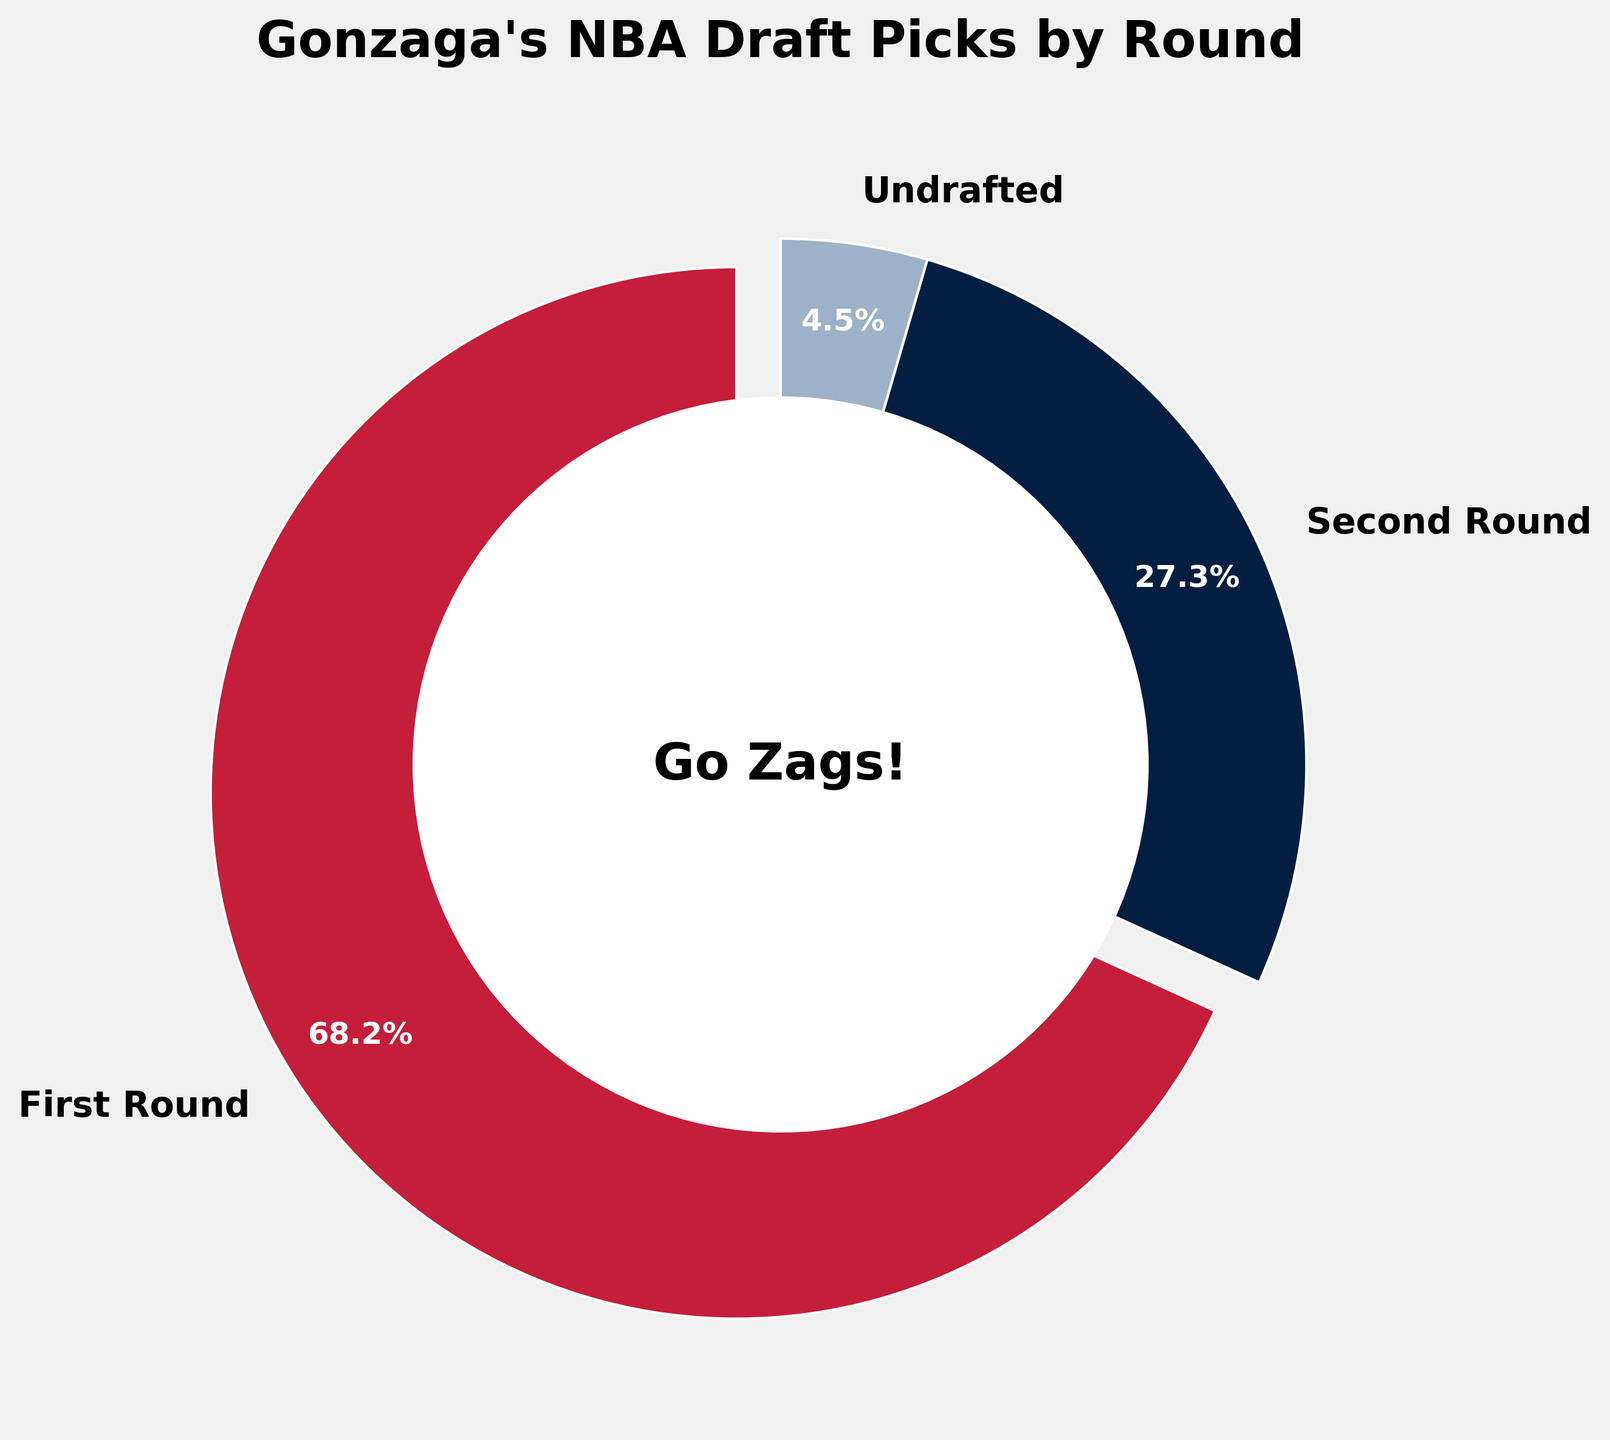What percentage of Gonzaga's NBA draft picks were undrafted? According to the pie chart, the section labeled 'Undrafted' shows 4.5%.
Answer: 4.5% Which draft round has the largest percentage of Gonzaga's NBA draft picks? The pie chart shows that the 'First Round' section is the largest, accounting for 68.2% of the picks.
Answer: First Round How much more percentage do First Round picks have compared to Second Round picks? First Round picks have 68.2% while Second Round picks have 27.3%. The difference is 68.2% - 27.3%
Answer: 40.9% What percentage of Gonzaga's NBA draft picks came in the First or Second Round combined? Add the percentages of First and Second Round picks: 68.2% + 27.3% = 95.5%
Answer: 95.5% What is the color representing 'Undrafted' in the pie chart? The 'Undrafted' portion of the pie chart is represented by a color that looks like light blue.
Answer: Light blue Is the percentage of Second Round picks greater than 25%? The pie chart shows that the percentage of Second Round picks is 27.3%, which is greater than 25%.
Answer: Yes What does the text at the center of the pie chart say? The center of the pie chart contains the text "Go Zags!".
Answer: Go Zags! Which draft round is displayed with an exploded view from the rest of the pie chart? The 'First Round' section of the pie chart is slightly separated from the rest, indicating an exploded view.
Answer: First Round 